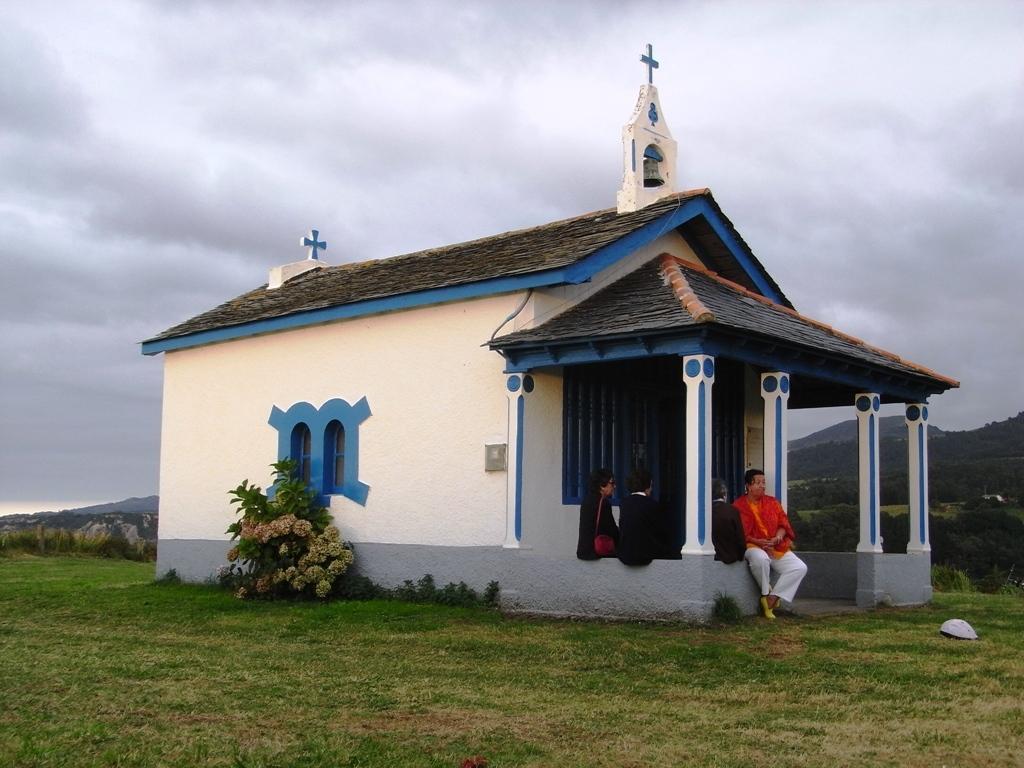Please provide a concise description of this image. In this picture there is a woman who is wearing red top, trouser and shoe. She is sitting on the wall, beside her we can see another women who are wearing a black dress. Here we can see a plant near to the window. In the center there is a church. On the bottom we can see grass. In the background we can see mountains and trees. On the top we can see sky and clouds. 